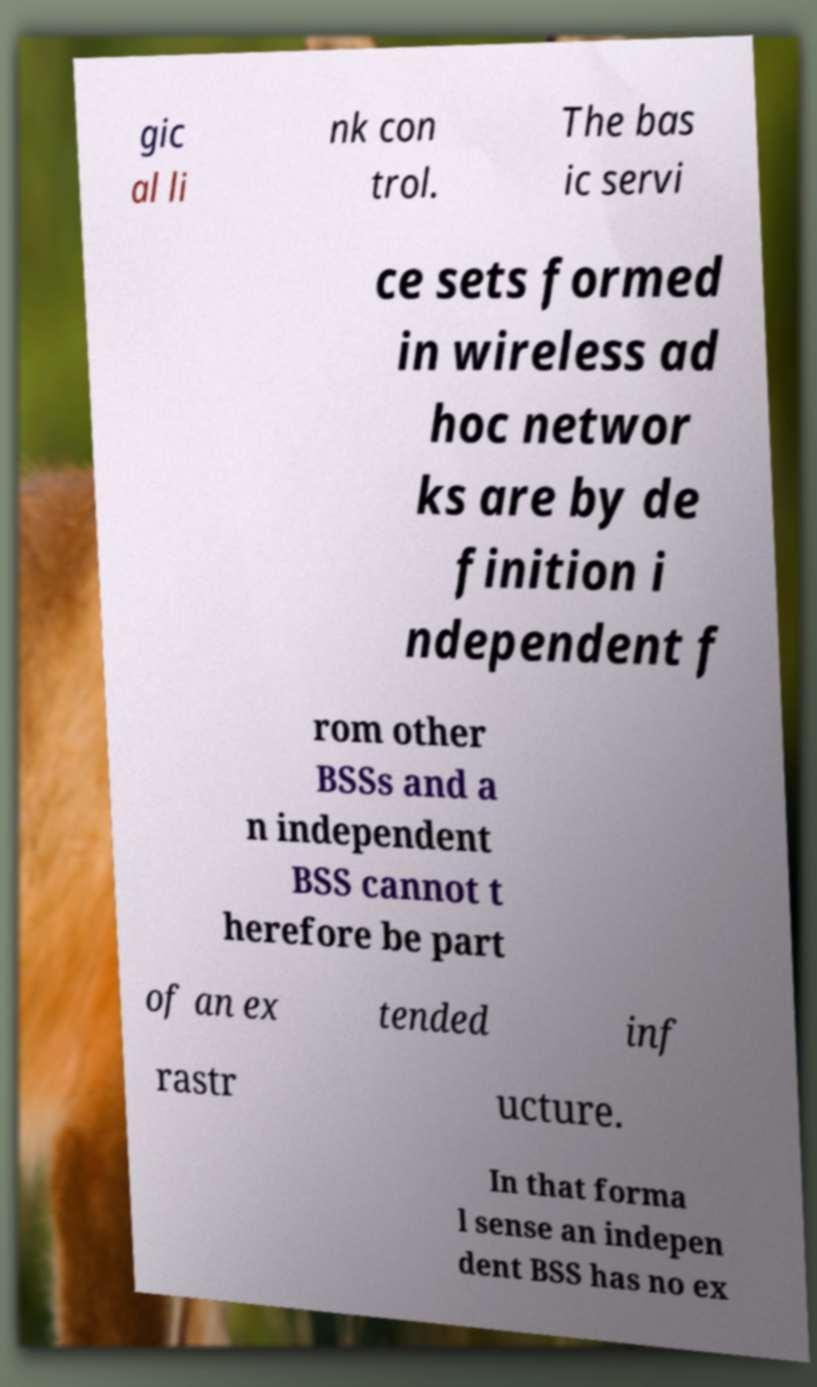What messages or text are displayed in this image? I need them in a readable, typed format. gic al li nk con trol. The bas ic servi ce sets formed in wireless ad hoc networ ks are by de finition i ndependent f rom other BSSs and a n independent BSS cannot t herefore be part of an ex tended inf rastr ucture. In that forma l sense an indepen dent BSS has no ex 